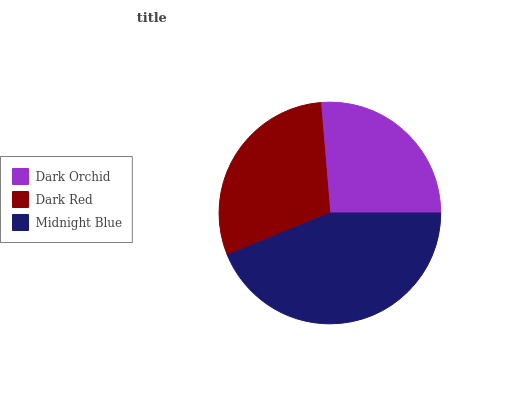Is Dark Orchid the minimum?
Answer yes or no. Yes. Is Midnight Blue the maximum?
Answer yes or no. Yes. Is Dark Red the minimum?
Answer yes or no. No. Is Dark Red the maximum?
Answer yes or no. No. Is Dark Red greater than Dark Orchid?
Answer yes or no. Yes. Is Dark Orchid less than Dark Red?
Answer yes or no. Yes. Is Dark Orchid greater than Dark Red?
Answer yes or no. No. Is Dark Red less than Dark Orchid?
Answer yes or no. No. Is Dark Red the high median?
Answer yes or no. Yes. Is Dark Red the low median?
Answer yes or no. Yes. Is Dark Orchid the high median?
Answer yes or no. No. Is Midnight Blue the low median?
Answer yes or no. No. 